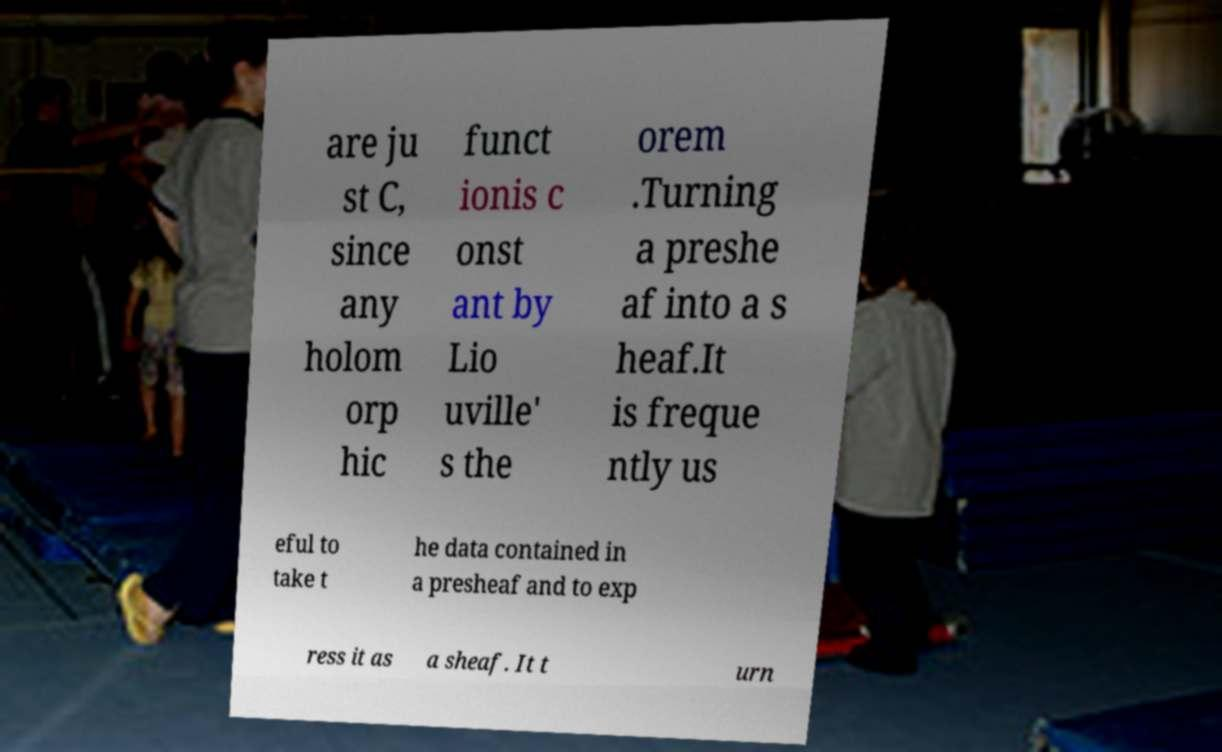I need the written content from this picture converted into text. Can you do that? are ju st C, since any holom orp hic funct ionis c onst ant by Lio uville' s the orem .Turning a preshe af into a s heaf.It is freque ntly us eful to take t he data contained in a presheaf and to exp ress it as a sheaf. It t urn 